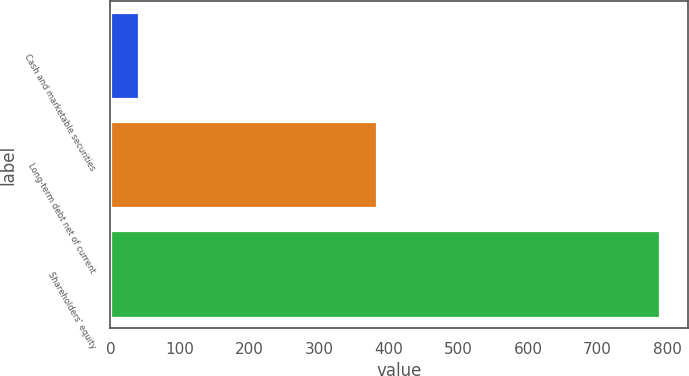Convert chart. <chart><loc_0><loc_0><loc_500><loc_500><bar_chart><fcel>Cash and marketable securities<fcel>Long-term debt net of current<fcel>Shareholders' equity<nl><fcel>41<fcel>383<fcel>790<nl></chart> 